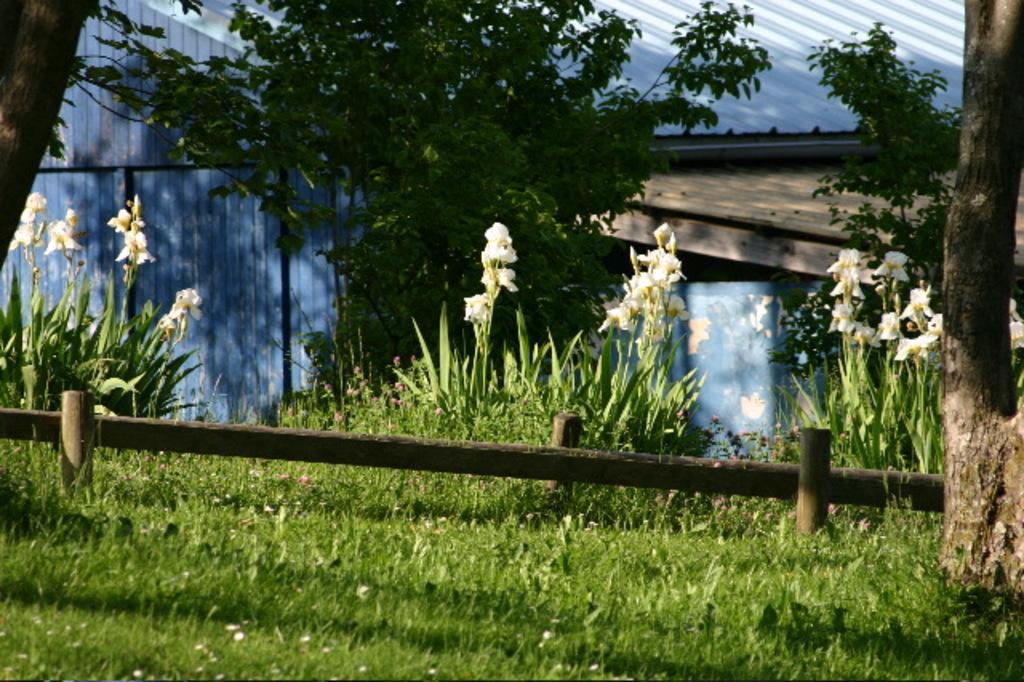What type of vegetation can be seen in the image? There are trees, flowers, and plants visible in the image. What type of structures are present in the image? There are wooden poles and a fence visible in the image. What type of popcorn can be seen growing on the trees in the image? There is no popcorn present in the image; it is a natural scene with trees, flowers, and plants. How does the hot weather affect the plants in the image? The provided facts do not mention the weather, so it cannot be determined how the plants might be affected by hot weather. 